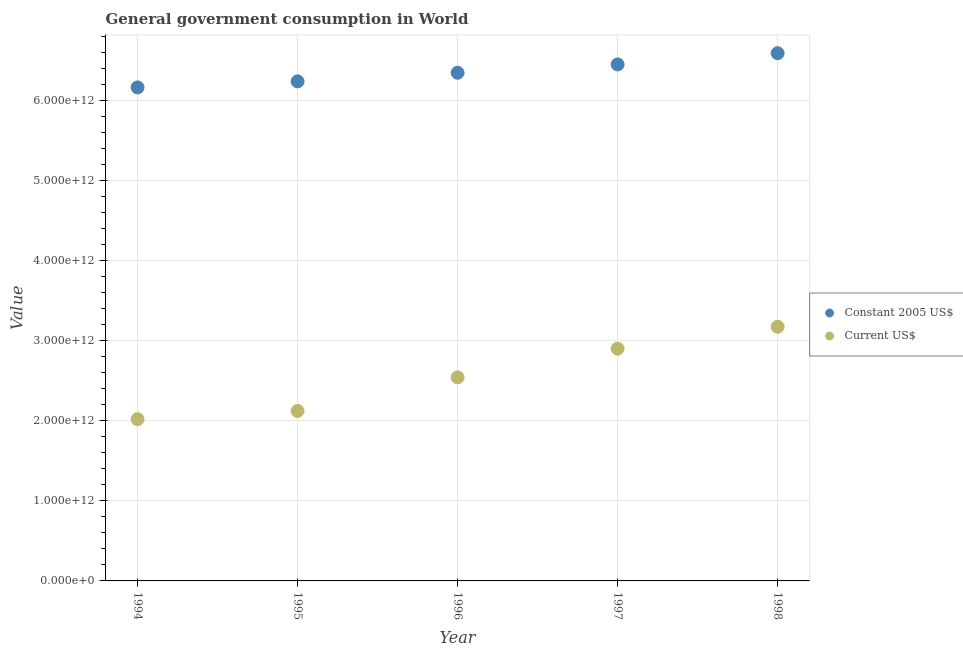How many different coloured dotlines are there?
Keep it short and to the point. 2. What is the value consumed in current us$ in 1995?
Give a very brief answer. 2.12e+12. Across all years, what is the maximum value consumed in current us$?
Make the answer very short. 3.17e+12. Across all years, what is the minimum value consumed in constant 2005 us$?
Your answer should be very brief. 6.16e+12. In which year was the value consumed in constant 2005 us$ minimum?
Provide a succinct answer. 1994. What is the total value consumed in constant 2005 us$ in the graph?
Make the answer very short. 3.18e+13. What is the difference between the value consumed in constant 2005 us$ in 1996 and that in 1998?
Give a very brief answer. -2.45e+11. What is the difference between the value consumed in current us$ in 1994 and the value consumed in constant 2005 us$ in 1998?
Your answer should be very brief. -4.57e+12. What is the average value consumed in current us$ per year?
Your answer should be very brief. 2.55e+12. In the year 1994, what is the difference between the value consumed in current us$ and value consumed in constant 2005 us$?
Make the answer very short. -4.14e+12. What is the ratio of the value consumed in constant 2005 us$ in 1994 to that in 1997?
Ensure brevity in your answer.  0.96. Is the value consumed in constant 2005 us$ in 1995 less than that in 1997?
Give a very brief answer. Yes. What is the difference between the highest and the second highest value consumed in constant 2005 us$?
Keep it short and to the point. 1.40e+11. What is the difference between the highest and the lowest value consumed in current us$?
Ensure brevity in your answer.  1.15e+12. How many years are there in the graph?
Give a very brief answer. 5. What is the difference between two consecutive major ticks on the Y-axis?
Provide a succinct answer. 1.00e+12. Are the values on the major ticks of Y-axis written in scientific E-notation?
Ensure brevity in your answer.  Yes. How many legend labels are there?
Provide a short and direct response. 2. How are the legend labels stacked?
Keep it short and to the point. Vertical. What is the title of the graph?
Your response must be concise. General government consumption in World. Does "% of GNI" appear as one of the legend labels in the graph?
Your answer should be very brief. No. What is the label or title of the X-axis?
Offer a terse response. Year. What is the label or title of the Y-axis?
Provide a short and direct response. Value. What is the Value in Constant 2005 US$ in 1994?
Offer a terse response. 6.16e+12. What is the Value in Current US$ in 1994?
Ensure brevity in your answer.  2.02e+12. What is the Value of Constant 2005 US$ in 1995?
Provide a succinct answer. 6.24e+12. What is the Value of Current US$ in 1995?
Your response must be concise. 2.12e+12. What is the Value of Constant 2005 US$ in 1996?
Offer a very short reply. 6.34e+12. What is the Value of Current US$ in 1996?
Provide a succinct answer. 2.54e+12. What is the Value in Constant 2005 US$ in 1997?
Give a very brief answer. 6.45e+12. What is the Value of Current US$ in 1997?
Your answer should be compact. 2.90e+12. What is the Value in Constant 2005 US$ in 1998?
Your answer should be very brief. 6.59e+12. What is the Value in Current US$ in 1998?
Provide a succinct answer. 3.17e+12. Across all years, what is the maximum Value in Constant 2005 US$?
Give a very brief answer. 6.59e+12. Across all years, what is the maximum Value of Current US$?
Offer a very short reply. 3.17e+12. Across all years, what is the minimum Value in Constant 2005 US$?
Your answer should be very brief. 6.16e+12. Across all years, what is the minimum Value in Current US$?
Offer a very short reply. 2.02e+12. What is the total Value of Constant 2005 US$ in the graph?
Provide a short and direct response. 3.18e+13. What is the total Value of Current US$ in the graph?
Give a very brief answer. 1.28e+13. What is the difference between the Value in Constant 2005 US$ in 1994 and that in 1995?
Keep it short and to the point. -7.53e+1. What is the difference between the Value in Current US$ in 1994 and that in 1995?
Give a very brief answer. -1.02e+11. What is the difference between the Value in Constant 2005 US$ in 1994 and that in 1996?
Your answer should be very brief. -1.82e+11. What is the difference between the Value of Current US$ in 1994 and that in 1996?
Provide a succinct answer. -5.22e+11. What is the difference between the Value of Constant 2005 US$ in 1994 and that in 1997?
Give a very brief answer. -2.87e+11. What is the difference between the Value in Current US$ in 1994 and that in 1997?
Ensure brevity in your answer.  -8.80e+11. What is the difference between the Value of Constant 2005 US$ in 1994 and that in 1998?
Provide a succinct answer. -4.27e+11. What is the difference between the Value of Current US$ in 1994 and that in 1998?
Ensure brevity in your answer.  -1.15e+12. What is the difference between the Value in Constant 2005 US$ in 1995 and that in 1996?
Your answer should be compact. -1.07e+11. What is the difference between the Value of Current US$ in 1995 and that in 1996?
Your response must be concise. -4.19e+11. What is the difference between the Value in Constant 2005 US$ in 1995 and that in 1997?
Your response must be concise. -2.11e+11. What is the difference between the Value of Current US$ in 1995 and that in 1997?
Your answer should be compact. -7.77e+11. What is the difference between the Value of Constant 2005 US$ in 1995 and that in 1998?
Ensure brevity in your answer.  -3.52e+11. What is the difference between the Value in Current US$ in 1995 and that in 1998?
Your answer should be very brief. -1.05e+12. What is the difference between the Value of Constant 2005 US$ in 1996 and that in 1997?
Provide a short and direct response. -1.04e+11. What is the difference between the Value in Current US$ in 1996 and that in 1997?
Make the answer very short. -3.58e+11. What is the difference between the Value in Constant 2005 US$ in 1996 and that in 1998?
Give a very brief answer. -2.45e+11. What is the difference between the Value in Current US$ in 1996 and that in 1998?
Give a very brief answer. -6.32e+11. What is the difference between the Value of Constant 2005 US$ in 1997 and that in 1998?
Give a very brief answer. -1.40e+11. What is the difference between the Value of Current US$ in 1997 and that in 1998?
Provide a succinct answer. -2.74e+11. What is the difference between the Value in Constant 2005 US$ in 1994 and the Value in Current US$ in 1995?
Offer a very short reply. 4.04e+12. What is the difference between the Value of Constant 2005 US$ in 1994 and the Value of Current US$ in 1996?
Your answer should be very brief. 3.62e+12. What is the difference between the Value of Constant 2005 US$ in 1994 and the Value of Current US$ in 1997?
Keep it short and to the point. 3.26e+12. What is the difference between the Value in Constant 2005 US$ in 1994 and the Value in Current US$ in 1998?
Your answer should be very brief. 2.99e+12. What is the difference between the Value in Constant 2005 US$ in 1995 and the Value in Current US$ in 1996?
Give a very brief answer. 3.69e+12. What is the difference between the Value of Constant 2005 US$ in 1995 and the Value of Current US$ in 1997?
Your answer should be compact. 3.34e+12. What is the difference between the Value of Constant 2005 US$ in 1995 and the Value of Current US$ in 1998?
Your answer should be compact. 3.06e+12. What is the difference between the Value of Constant 2005 US$ in 1996 and the Value of Current US$ in 1997?
Ensure brevity in your answer.  3.44e+12. What is the difference between the Value in Constant 2005 US$ in 1996 and the Value in Current US$ in 1998?
Provide a short and direct response. 3.17e+12. What is the difference between the Value of Constant 2005 US$ in 1997 and the Value of Current US$ in 1998?
Give a very brief answer. 3.27e+12. What is the average Value in Constant 2005 US$ per year?
Your answer should be compact. 6.35e+12. What is the average Value of Current US$ per year?
Give a very brief answer. 2.55e+12. In the year 1994, what is the difference between the Value of Constant 2005 US$ and Value of Current US$?
Provide a succinct answer. 4.14e+12. In the year 1995, what is the difference between the Value in Constant 2005 US$ and Value in Current US$?
Your answer should be compact. 4.11e+12. In the year 1996, what is the difference between the Value in Constant 2005 US$ and Value in Current US$?
Your answer should be very brief. 3.80e+12. In the year 1997, what is the difference between the Value of Constant 2005 US$ and Value of Current US$?
Keep it short and to the point. 3.55e+12. In the year 1998, what is the difference between the Value of Constant 2005 US$ and Value of Current US$?
Offer a very short reply. 3.41e+12. What is the ratio of the Value of Constant 2005 US$ in 1994 to that in 1995?
Provide a short and direct response. 0.99. What is the ratio of the Value in Current US$ in 1994 to that in 1995?
Make the answer very short. 0.95. What is the ratio of the Value of Constant 2005 US$ in 1994 to that in 1996?
Provide a short and direct response. 0.97. What is the ratio of the Value of Current US$ in 1994 to that in 1996?
Your answer should be very brief. 0.79. What is the ratio of the Value in Constant 2005 US$ in 1994 to that in 1997?
Offer a very short reply. 0.96. What is the ratio of the Value of Current US$ in 1994 to that in 1997?
Provide a short and direct response. 0.7. What is the ratio of the Value in Constant 2005 US$ in 1994 to that in 1998?
Make the answer very short. 0.94. What is the ratio of the Value in Current US$ in 1994 to that in 1998?
Offer a terse response. 0.64. What is the ratio of the Value of Constant 2005 US$ in 1995 to that in 1996?
Provide a short and direct response. 0.98. What is the ratio of the Value in Current US$ in 1995 to that in 1996?
Provide a succinct answer. 0.83. What is the ratio of the Value of Constant 2005 US$ in 1995 to that in 1997?
Give a very brief answer. 0.97. What is the ratio of the Value of Current US$ in 1995 to that in 1997?
Provide a short and direct response. 0.73. What is the ratio of the Value of Constant 2005 US$ in 1995 to that in 1998?
Keep it short and to the point. 0.95. What is the ratio of the Value in Current US$ in 1995 to that in 1998?
Offer a very short reply. 0.67. What is the ratio of the Value in Constant 2005 US$ in 1996 to that in 1997?
Offer a very short reply. 0.98. What is the ratio of the Value of Current US$ in 1996 to that in 1997?
Your answer should be very brief. 0.88. What is the ratio of the Value of Constant 2005 US$ in 1996 to that in 1998?
Ensure brevity in your answer.  0.96. What is the ratio of the Value of Current US$ in 1996 to that in 1998?
Make the answer very short. 0.8. What is the ratio of the Value of Constant 2005 US$ in 1997 to that in 1998?
Make the answer very short. 0.98. What is the ratio of the Value in Current US$ in 1997 to that in 1998?
Your response must be concise. 0.91. What is the difference between the highest and the second highest Value of Constant 2005 US$?
Make the answer very short. 1.40e+11. What is the difference between the highest and the second highest Value of Current US$?
Offer a terse response. 2.74e+11. What is the difference between the highest and the lowest Value in Constant 2005 US$?
Your answer should be compact. 4.27e+11. What is the difference between the highest and the lowest Value in Current US$?
Provide a succinct answer. 1.15e+12. 